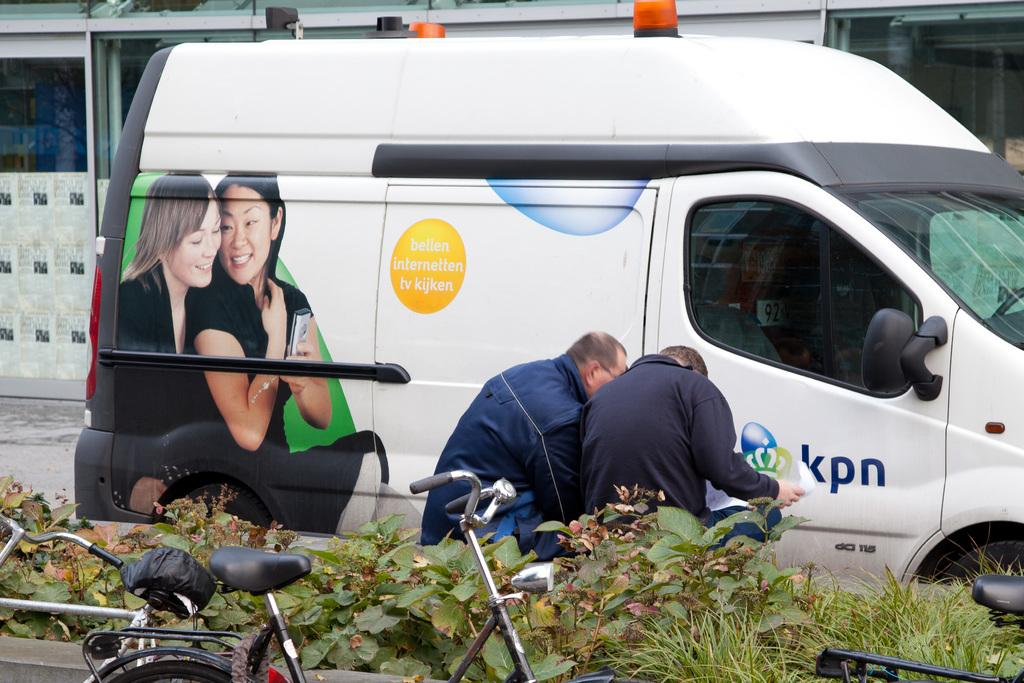<image>
Render a clear and concise summary of the photo. A white van has a yellow circle with bellen internellen tv. 